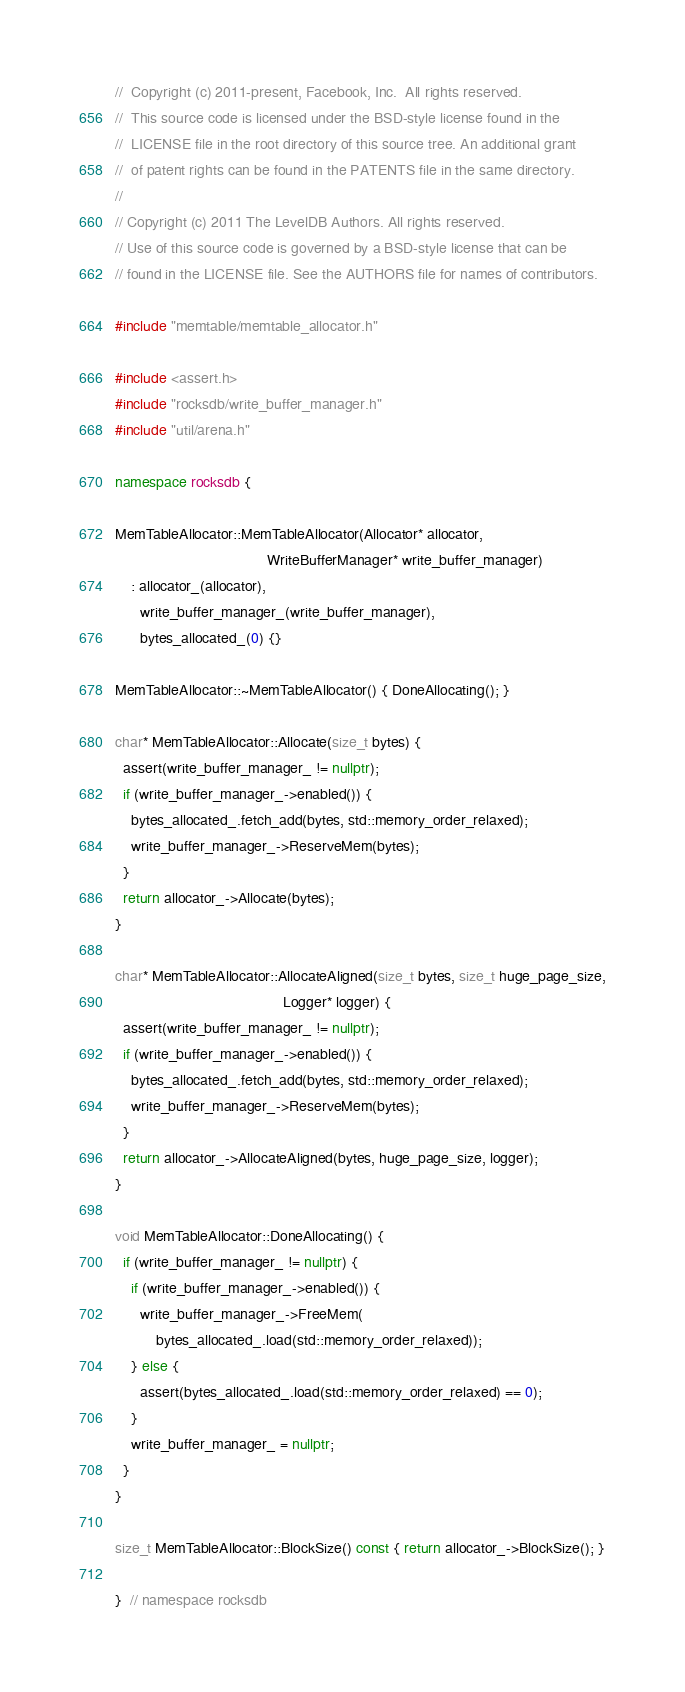Convert code to text. <code><loc_0><loc_0><loc_500><loc_500><_C++_>//  Copyright (c) 2011-present, Facebook, Inc.  All rights reserved.
//  This source code is licensed under the BSD-style license found in the
//  LICENSE file in the root directory of this source tree. An additional grant
//  of patent rights can be found in the PATENTS file in the same directory.
//
// Copyright (c) 2011 The LevelDB Authors. All rights reserved.
// Use of this source code is governed by a BSD-style license that can be
// found in the LICENSE file. See the AUTHORS file for names of contributors.

#include "memtable/memtable_allocator.h"

#include <assert.h>
#include "rocksdb/write_buffer_manager.h"
#include "util/arena.h"

namespace rocksdb {

MemTableAllocator::MemTableAllocator(Allocator* allocator,
                                     WriteBufferManager* write_buffer_manager)
    : allocator_(allocator),
      write_buffer_manager_(write_buffer_manager),
      bytes_allocated_(0) {}

MemTableAllocator::~MemTableAllocator() { DoneAllocating(); }

char* MemTableAllocator::Allocate(size_t bytes) {
  assert(write_buffer_manager_ != nullptr);
  if (write_buffer_manager_->enabled()) {
    bytes_allocated_.fetch_add(bytes, std::memory_order_relaxed);
    write_buffer_manager_->ReserveMem(bytes);
  }
  return allocator_->Allocate(bytes);
}

char* MemTableAllocator::AllocateAligned(size_t bytes, size_t huge_page_size,
                                         Logger* logger) {
  assert(write_buffer_manager_ != nullptr);
  if (write_buffer_manager_->enabled()) {
    bytes_allocated_.fetch_add(bytes, std::memory_order_relaxed);
    write_buffer_manager_->ReserveMem(bytes);
  }
  return allocator_->AllocateAligned(bytes, huge_page_size, logger);
}

void MemTableAllocator::DoneAllocating() {
  if (write_buffer_manager_ != nullptr) {
    if (write_buffer_manager_->enabled()) {
      write_buffer_manager_->FreeMem(
          bytes_allocated_.load(std::memory_order_relaxed));
    } else {
      assert(bytes_allocated_.load(std::memory_order_relaxed) == 0);
    }
    write_buffer_manager_ = nullptr;
  }
}

size_t MemTableAllocator::BlockSize() const { return allocator_->BlockSize(); }

}  // namespace rocksdb
</code> 